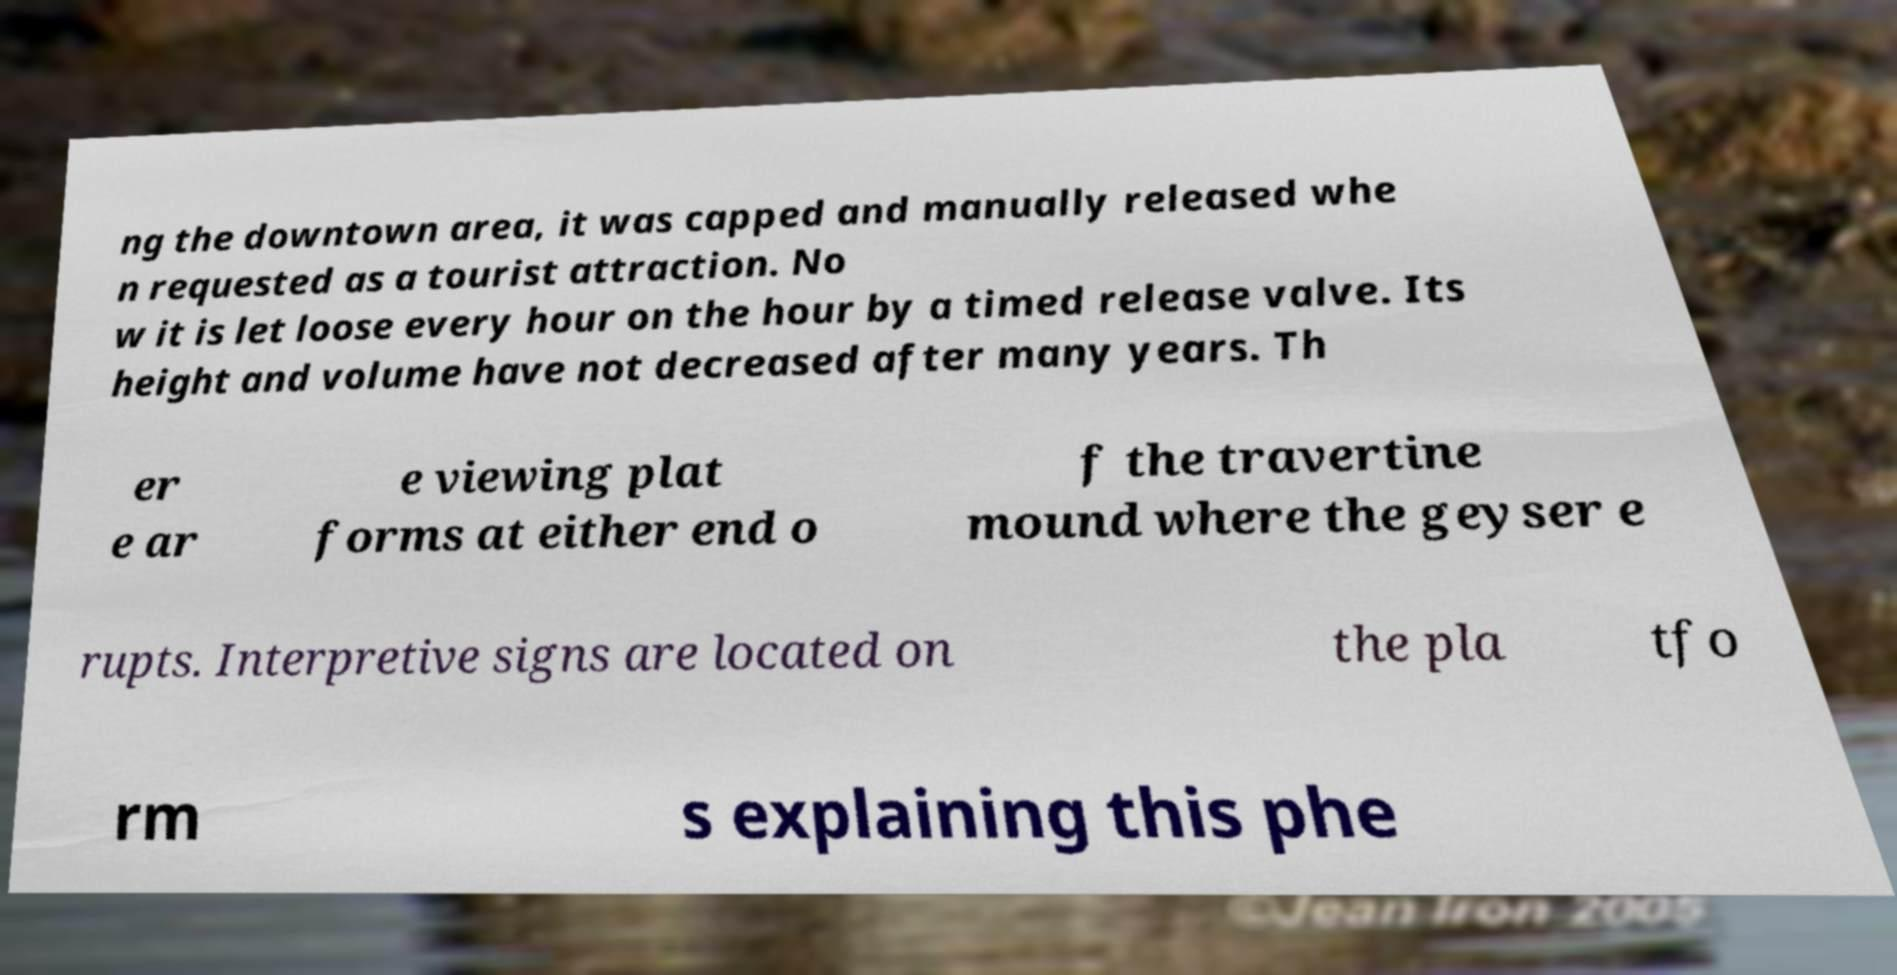Can you read and provide the text displayed in the image?This photo seems to have some interesting text. Can you extract and type it out for me? ng the downtown area, it was capped and manually released whe n requested as a tourist attraction. No w it is let loose every hour on the hour by a timed release valve. Its height and volume have not decreased after many years. Th er e ar e viewing plat forms at either end o f the travertine mound where the geyser e rupts. Interpretive signs are located on the pla tfo rm s explaining this phe 